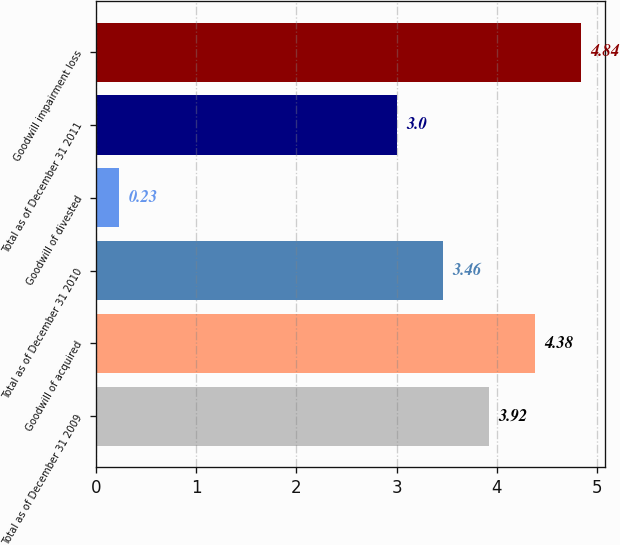Convert chart. <chart><loc_0><loc_0><loc_500><loc_500><bar_chart><fcel>Total as of December 31 2009<fcel>Goodwill of acquired<fcel>Total as of December 31 2010<fcel>Goodwill of divested<fcel>Total as of December 31 2011<fcel>Goodwill impairment loss<nl><fcel>3.92<fcel>4.38<fcel>3.46<fcel>0.23<fcel>3<fcel>4.84<nl></chart> 